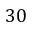<formula> <loc_0><loc_0><loc_500><loc_500>3 0</formula> 